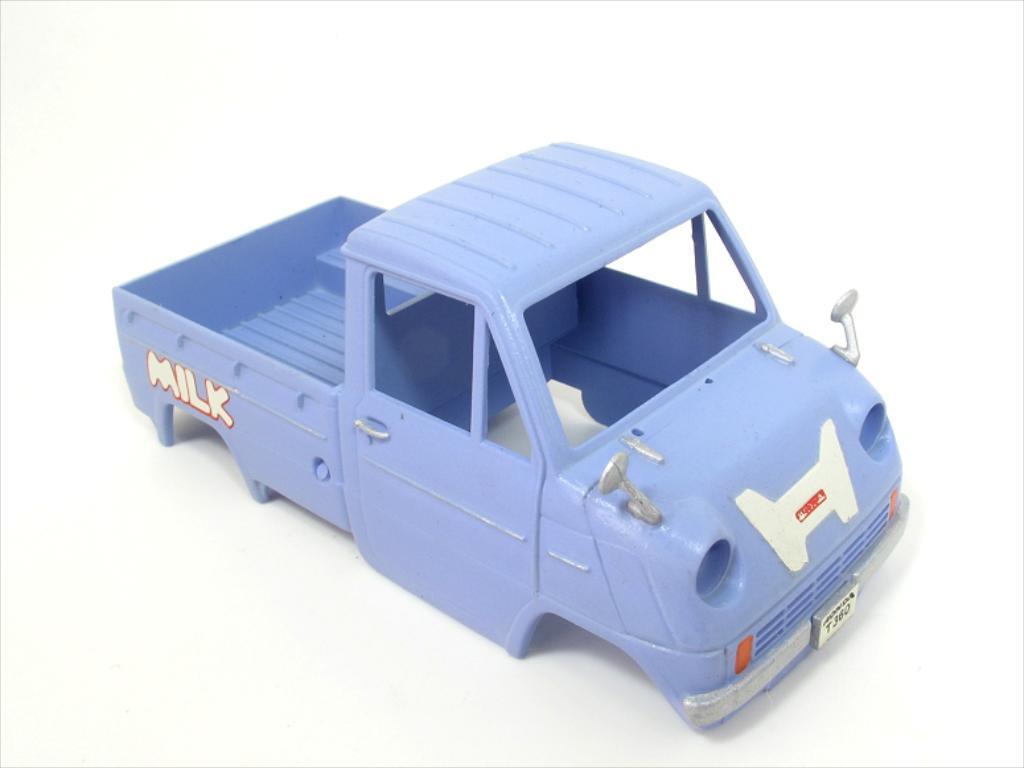Could you give a brief overview of what you see in this image? Here we can see a toy vehicle with no tires,glasses,lights to fit on a platform. 